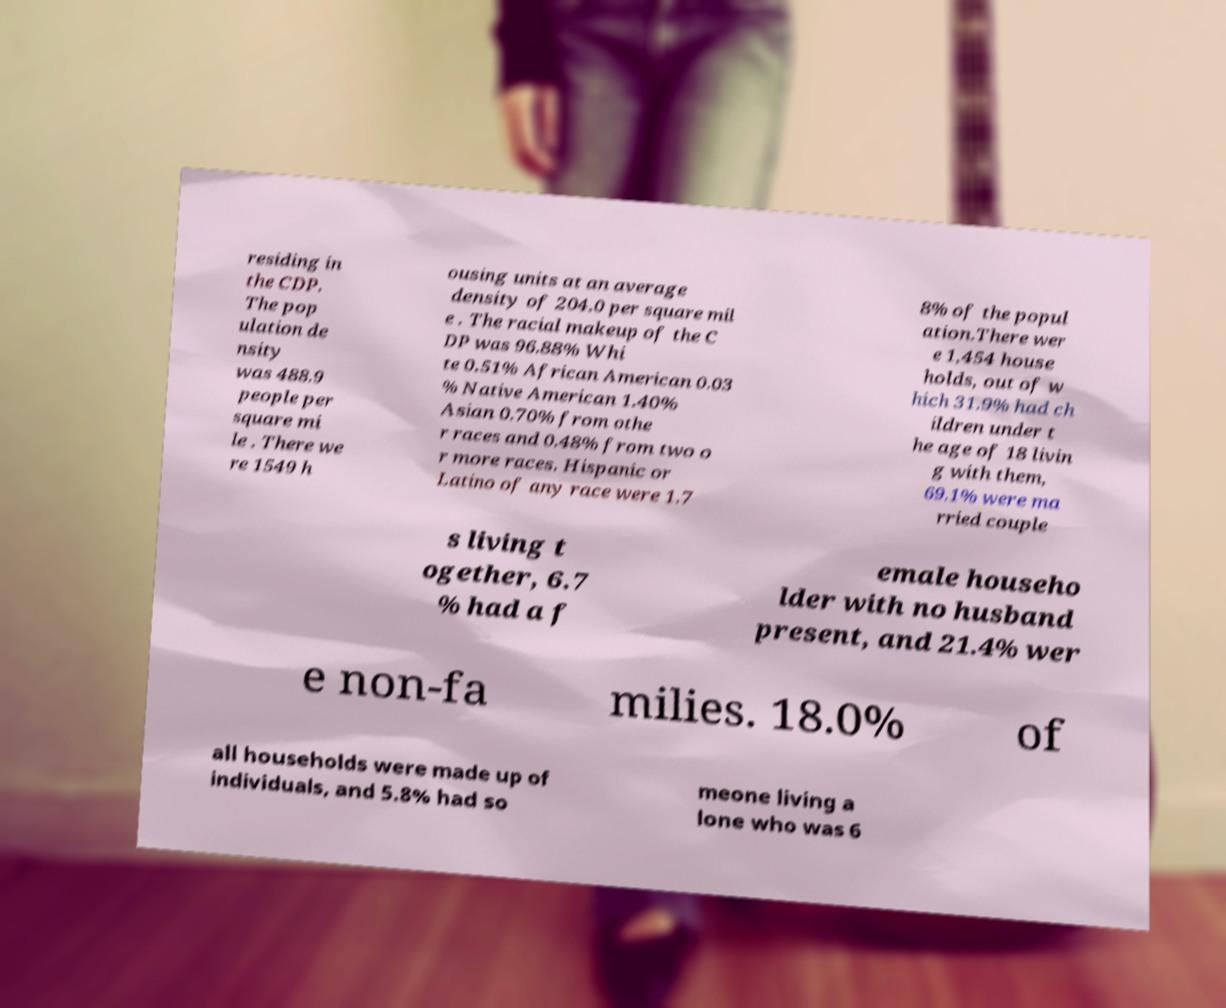Please identify and transcribe the text found in this image. residing in the CDP. The pop ulation de nsity was 488.9 people per square mi le . There we re 1549 h ousing units at an average density of 204.0 per square mil e . The racial makeup of the C DP was 96.88% Whi te 0.51% African American 0.03 % Native American 1.40% Asian 0.70% from othe r races and 0.48% from two o r more races. Hispanic or Latino of any race were 1.7 8% of the popul ation.There wer e 1,454 house holds, out of w hich 31.9% had ch ildren under t he age of 18 livin g with them, 69.1% were ma rried couple s living t ogether, 6.7 % had a f emale househo lder with no husband present, and 21.4% wer e non-fa milies. 18.0% of all households were made up of individuals, and 5.8% had so meone living a lone who was 6 